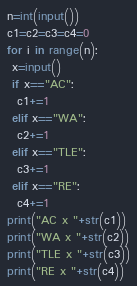<code> <loc_0><loc_0><loc_500><loc_500><_Python_>n=int(input())
c1=c2=c3=c4=0
for i in range(n):
 x=input()
 if x=="AC":
  c1+=1
 elif x=="WA":
  c2+=1
 elif x=="TLE":
  c3+=1
 elif x=="RE":
  c4+=1
print("AC x "+str(c1))
print("WA x "+str(c2))
print("TLE x "+str(c3))
print("RE x "+str(c4))</code> 